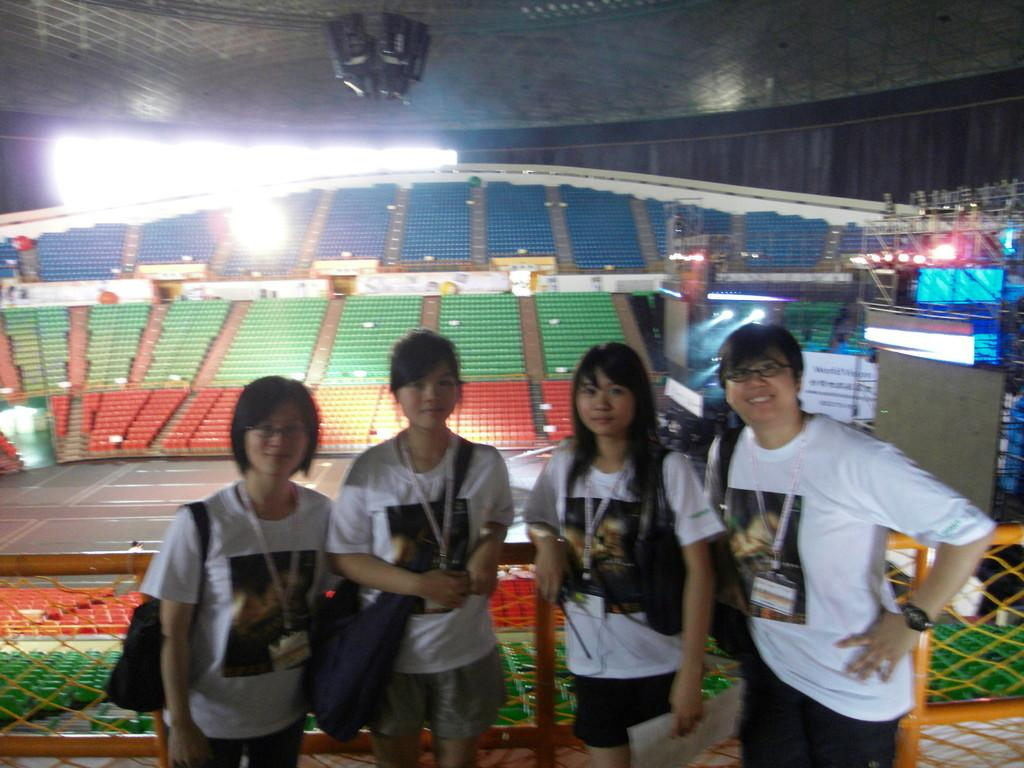How many people are in the center of the image? There are four members in the middle of the image. What can be seen in the background of the image? There is an indoor stadium and lights visible in the background of the image. What type of cord is being used by the hen in the image? There is no hen present in the image, so there is no cord being used by a hen. 